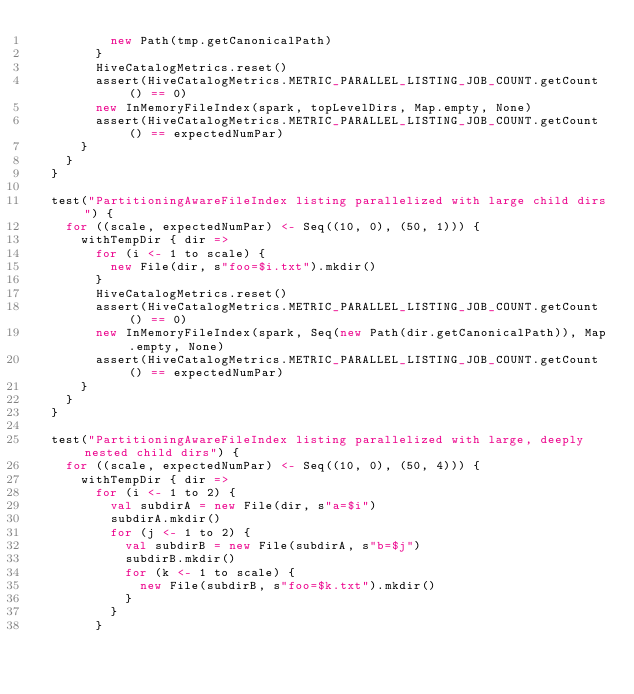Convert code to text. <code><loc_0><loc_0><loc_500><loc_500><_Scala_>          new Path(tmp.getCanonicalPath)
        }
        HiveCatalogMetrics.reset()
        assert(HiveCatalogMetrics.METRIC_PARALLEL_LISTING_JOB_COUNT.getCount() == 0)
        new InMemoryFileIndex(spark, topLevelDirs, Map.empty, None)
        assert(HiveCatalogMetrics.METRIC_PARALLEL_LISTING_JOB_COUNT.getCount() == expectedNumPar)
      }
    }
  }

  test("PartitioningAwareFileIndex listing parallelized with large child dirs") {
    for ((scale, expectedNumPar) <- Seq((10, 0), (50, 1))) {
      withTempDir { dir =>
        for (i <- 1 to scale) {
          new File(dir, s"foo=$i.txt").mkdir()
        }
        HiveCatalogMetrics.reset()
        assert(HiveCatalogMetrics.METRIC_PARALLEL_LISTING_JOB_COUNT.getCount() == 0)
        new InMemoryFileIndex(spark, Seq(new Path(dir.getCanonicalPath)), Map.empty, None)
        assert(HiveCatalogMetrics.METRIC_PARALLEL_LISTING_JOB_COUNT.getCount() == expectedNumPar)
      }
    }
  }

  test("PartitioningAwareFileIndex listing parallelized with large, deeply nested child dirs") {
    for ((scale, expectedNumPar) <- Seq((10, 0), (50, 4))) {
      withTempDir { dir =>
        for (i <- 1 to 2) {
          val subdirA = new File(dir, s"a=$i")
          subdirA.mkdir()
          for (j <- 1 to 2) {
            val subdirB = new File(subdirA, s"b=$j")
            subdirB.mkdir()
            for (k <- 1 to scale) {
              new File(subdirB, s"foo=$k.txt").mkdir()
            }
          }
        }</code> 